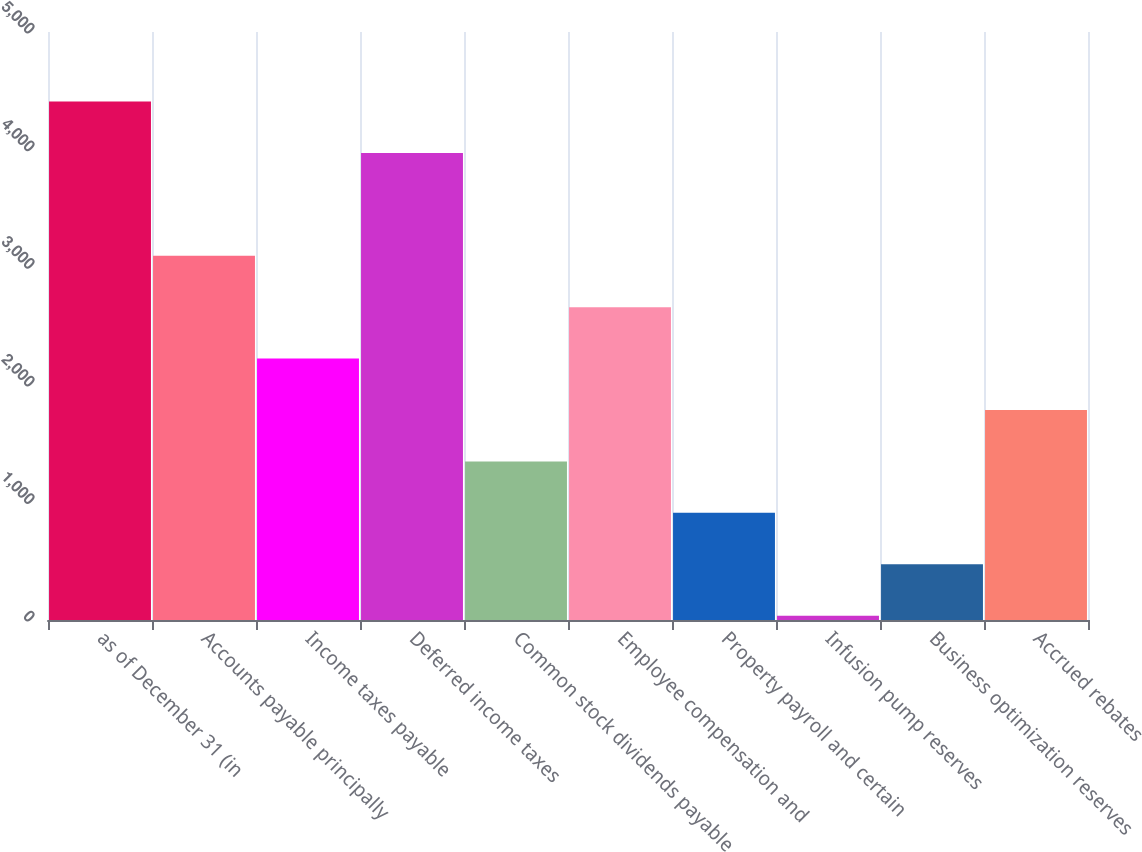Convert chart to OTSL. <chart><loc_0><loc_0><loc_500><loc_500><bar_chart><fcel>as of December 31 (in<fcel>Accounts payable principally<fcel>Income taxes payable<fcel>Deferred income taxes<fcel>Common stock dividends payable<fcel>Employee compensation and<fcel>Property payroll and certain<fcel>Infusion pump reserves<fcel>Business optimization reserves<fcel>Accrued rebates<nl><fcel>4409<fcel>3097.4<fcel>2223<fcel>3971.8<fcel>1348.6<fcel>2660.2<fcel>911.4<fcel>37<fcel>474.2<fcel>1785.8<nl></chart> 